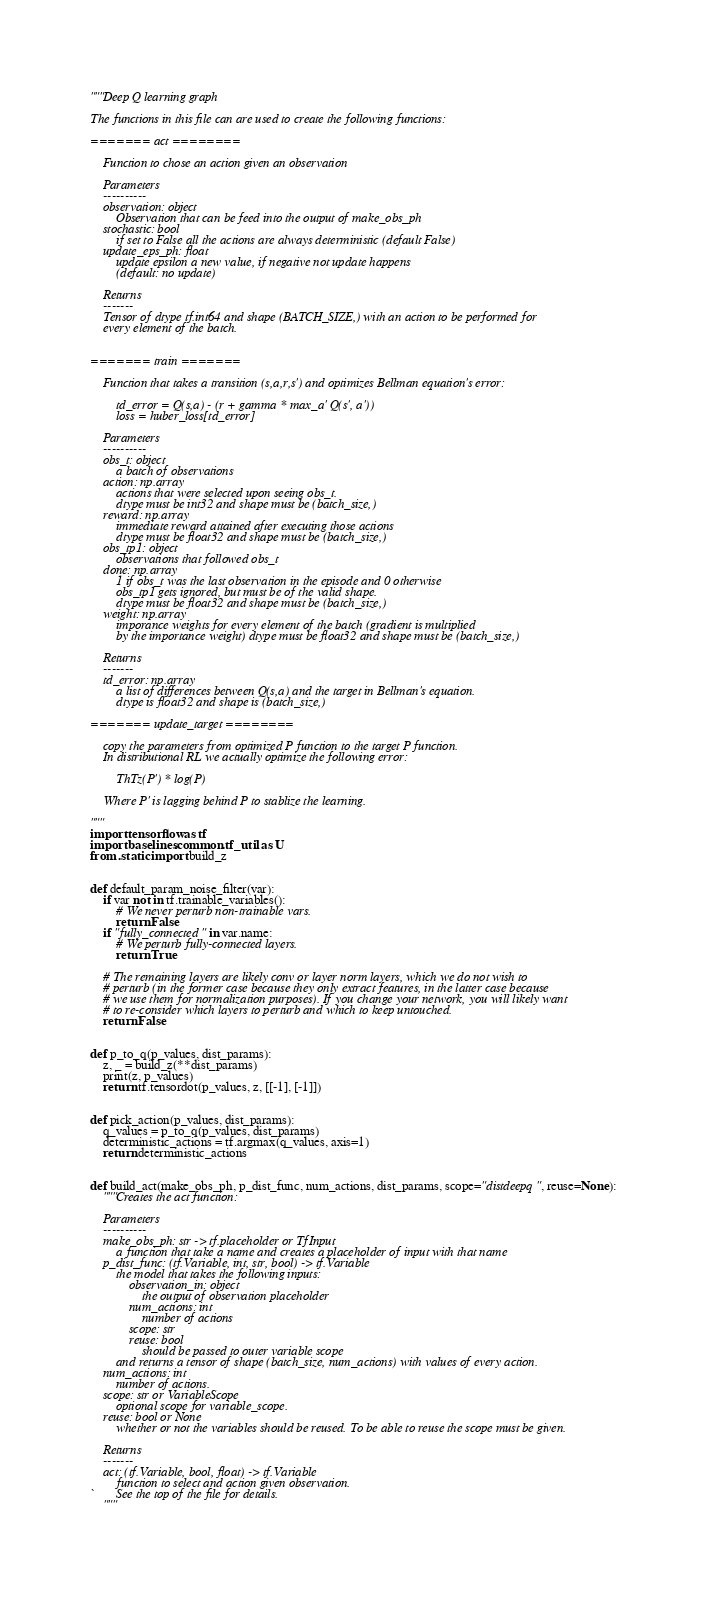<code> <loc_0><loc_0><loc_500><loc_500><_Python_>"""Deep Q learning graph

The functions in this file can are used to create the following functions:

======= act ========

    Function to chose an action given an observation

    Parameters
    ----------
    observation: object
        Observation that can be feed into the output of make_obs_ph
    stochastic: bool
        if set to False all the actions are always deterministic (default False)
    update_eps_ph: float
        update epsilon a new value, if negative not update happens
        (default: no update)

    Returns
    -------
    Tensor of dtype tf.int64 and shape (BATCH_SIZE,) with an action to be performed for
    every element of the batch.


======= train =======

    Function that takes a transition (s,a,r,s') and optimizes Bellman equation's error:

        td_error = Q(s,a) - (r + gamma * max_a' Q(s', a'))
        loss = huber_loss[td_error]

    Parameters
    ----------
    obs_t: object
        a batch of observations
    action: np.array
        actions that were selected upon seeing obs_t.
        dtype must be int32 and shape must be (batch_size,)
    reward: np.array
        immediate reward attained after executing those actions
        dtype must be float32 and shape must be (batch_size,)
    obs_tp1: object
        observations that followed obs_t
    done: np.array
        1 if obs_t was the last observation in the episode and 0 otherwise
        obs_tp1 gets ignored, but must be of the valid shape.
        dtype must be float32 and shape must be (batch_size,)
    weight: np.array
        imporance weights for every element of the batch (gradient is multiplied
        by the importance weight) dtype must be float32 and shape must be (batch_size,)

    Returns
    -------
    td_error: np.array
        a list of differences between Q(s,a) and the target in Bellman's equation.
        dtype is float32 and shape is (batch_size,)

======= update_target ========

    copy the parameters from optimized P function to the target P function.
    In distributional RL we actually optimize the following error:

        ThTz(P') * log(P)

    Where P' is lagging behind P to stablize the learning.

"""
import tensorflow as tf
import baselines.common.tf_util as U
from .static import build_z


def default_param_noise_filter(var):
    if var not in tf.trainable_variables():
        # We never perturb non-trainable vars.
        return False
    if "fully_connected" in var.name:
        # We perturb fully-connected layers.
        return True

    # The remaining layers are likely conv or layer norm layers, which we do not wish to
    # perturb (in the former case because they only extract features, in the latter case because
    # we use them for normalization purposes). If you change your network, you will likely want
    # to re-consider which layers to perturb and which to keep untouched.
    return False


def p_to_q(p_values, dist_params):
    z, _ = build_z(**dist_params)
    print(z, p_values)
    return tf.tensordot(p_values, z, [[-1], [-1]])


def pick_action(p_values, dist_params):
    q_values = p_to_q(p_values, dist_params)
    deterministic_actions = tf.argmax(q_values, axis=1)
    return deterministic_actions


def build_act(make_obs_ph, p_dist_func, num_actions, dist_params, scope="distdeepq", reuse=None):
    """Creates the act function:

    Parameters
    ----------
    make_obs_ph: str -> tf.placeholder or TfInput
        a function that take a name and creates a placeholder of input with that name
    p_dist_func: (tf.Variable, int, str, bool) -> tf.Variable
        the model that takes the following inputs:
            observation_in: object
                the output of observation placeholder
            num_actions: int
                number of actions
            scope: str
            reuse: bool
                should be passed to outer variable scope
        and returns a tensor of shape (batch_size, num_actions) with values of every action.
    num_actions: int
        number of actions.
    scope: str or VariableScope
        optional scope for variable_scope.
    reuse: bool or None
        whether or not the variables should be reused. To be able to reuse the scope must be given.

    Returns
    -------
    act: (tf.Variable, bool, float) -> tf.Variable
        function to select and action given observation.
`       See the top of the file for details.
    """</code> 